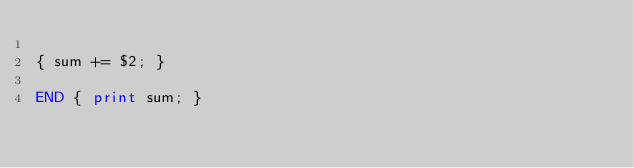Convert code to text. <code><loc_0><loc_0><loc_500><loc_500><_Awk_>
{ sum += $2; }

END { print sum; }
</code> 